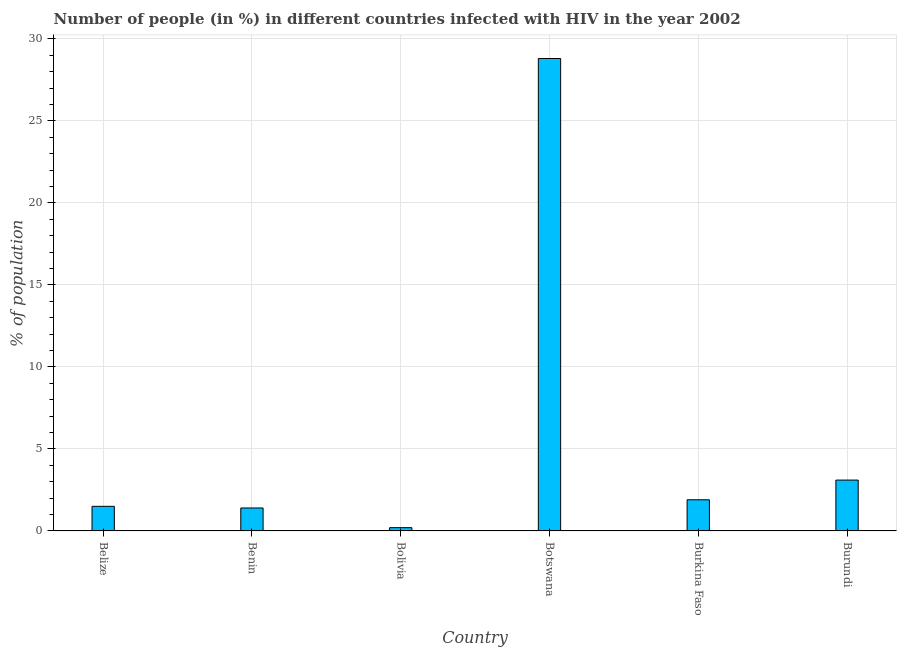Does the graph contain any zero values?
Ensure brevity in your answer.  No. Does the graph contain grids?
Provide a succinct answer. Yes. What is the title of the graph?
Your response must be concise. Number of people (in %) in different countries infected with HIV in the year 2002. What is the label or title of the Y-axis?
Ensure brevity in your answer.  % of population. Across all countries, what is the maximum number of people infected with hiv?
Your answer should be very brief. 28.8. Across all countries, what is the minimum number of people infected with hiv?
Your answer should be very brief. 0.2. In which country was the number of people infected with hiv maximum?
Your response must be concise. Botswana. In which country was the number of people infected with hiv minimum?
Make the answer very short. Bolivia. What is the sum of the number of people infected with hiv?
Offer a very short reply. 36.9. What is the difference between the number of people infected with hiv in Belize and Bolivia?
Provide a succinct answer. 1.3. What is the average number of people infected with hiv per country?
Your response must be concise. 6.15. What is the median number of people infected with hiv?
Your answer should be very brief. 1.7. What is the ratio of the number of people infected with hiv in Benin to that in Burundi?
Provide a short and direct response. 0.45. Is the number of people infected with hiv in Belize less than that in Burkina Faso?
Your answer should be very brief. Yes. Is the difference between the number of people infected with hiv in Belize and Burundi greater than the difference between any two countries?
Offer a very short reply. No. What is the difference between the highest and the second highest number of people infected with hiv?
Make the answer very short. 25.7. What is the difference between the highest and the lowest number of people infected with hiv?
Your answer should be very brief. 28.6. In how many countries, is the number of people infected with hiv greater than the average number of people infected with hiv taken over all countries?
Provide a short and direct response. 1. How many bars are there?
Make the answer very short. 6. Are all the bars in the graph horizontal?
Ensure brevity in your answer.  No. What is the difference between two consecutive major ticks on the Y-axis?
Ensure brevity in your answer.  5. Are the values on the major ticks of Y-axis written in scientific E-notation?
Keep it short and to the point. No. What is the % of population of Bolivia?
Offer a very short reply. 0.2. What is the % of population in Botswana?
Offer a terse response. 28.8. What is the % of population in Burundi?
Your response must be concise. 3.1. What is the difference between the % of population in Belize and Bolivia?
Your answer should be very brief. 1.3. What is the difference between the % of population in Belize and Botswana?
Keep it short and to the point. -27.3. What is the difference between the % of population in Belize and Burkina Faso?
Your answer should be compact. -0.4. What is the difference between the % of population in Benin and Bolivia?
Your answer should be very brief. 1.2. What is the difference between the % of population in Benin and Botswana?
Offer a very short reply. -27.4. What is the difference between the % of population in Bolivia and Botswana?
Offer a terse response. -28.6. What is the difference between the % of population in Bolivia and Burkina Faso?
Give a very brief answer. -1.7. What is the difference between the % of population in Botswana and Burkina Faso?
Provide a succinct answer. 26.9. What is the difference between the % of population in Botswana and Burundi?
Keep it short and to the point. 25.7. What is the difference between the % of population in Burkina Faso and Burundi?
Give a very brief answer. -1.2. What is the ratio of the % of population in Belize to that in Benin?
Offer a terse response. 1.07. What is the ratio of the % of population in Belize to that in Bolivia?
Your response must be concise. 7.5. What is the ratio of the % of population in Belize to that in Botswana?
Offer a very short reply. 0.05. What is the ratio of the % of population in Belize to that in Burkina Faso?
Make the answer very short. 0.79. What is the ratio of the % of population in Belize to that in Burundi?
Offer a very short reply. 0.48. What is the ratio of the % of population in Benin to that in Botswana?
Provide a short and direct response. 0.05. What is the ratio of the % of population in Benin to that in Burkina Faso?
Offer a terse response. 0.74. What is the ratio of the % of population in Benin to that in Burundi?
Provide a succinct answer. 0.45. What is the ratio of the % of population in Bolivia to that in Botswana?
Ensure brevity in your answer.  0.01. What is the ratio of the % of population in Bolivia to that in Burkina Faso?
Provide a succinct answer. 0.1. What is the ratio of the % of population in Bolivia to that in Burundi?
Your answer should be compact. 0.07. What is the ratio of the % of population in Botswana to that in Burkina Faso?
Your response must be concise. 15.16. What is the ratio of the % of population in Botswana to that in Burundi?
Your answer should be very brief. 9.29. What is the ratio of the % of population in Burkina Faso to that in Burundi?
Keep it short and to the point. 0.61. 